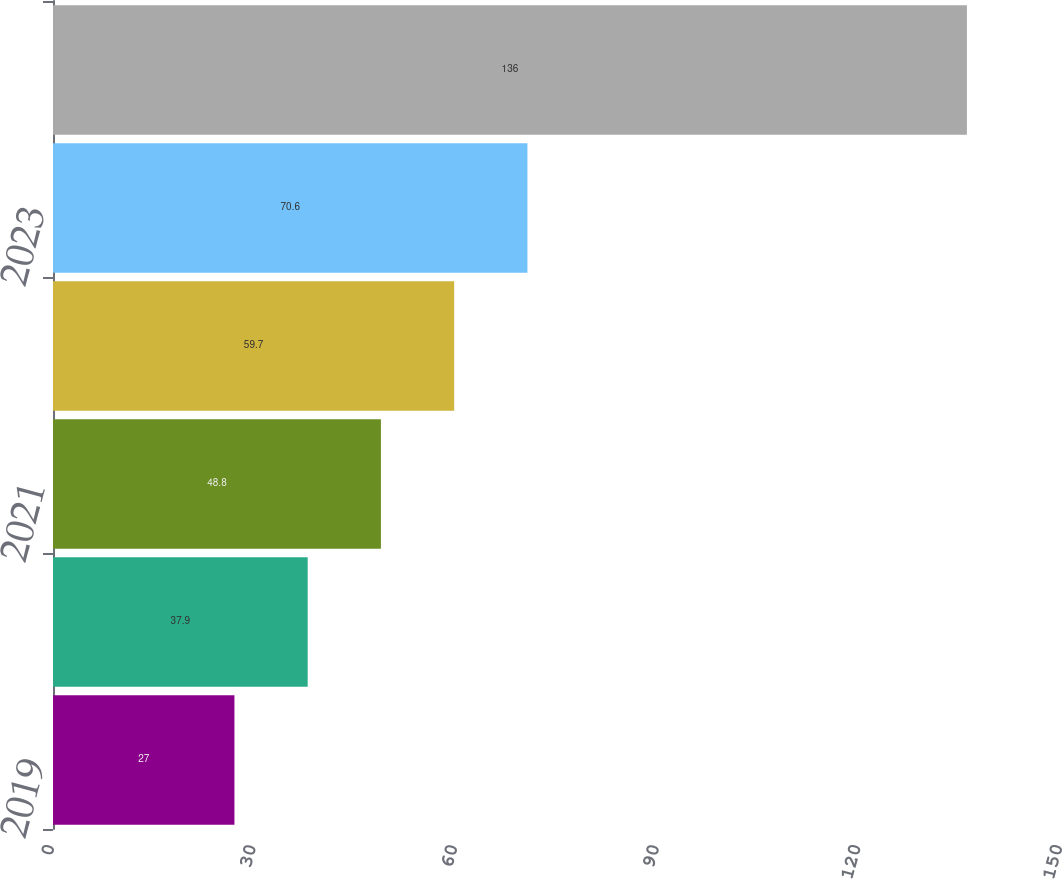<chart> <loc_0><loc_0><loc_500><loc_500><bar_chart><fcel>2019<fcel>2020<fcel>2021<fcel>2022<fcel>2023<fcel>2024-2028<nl><fcel>27<fcel>37.9<fcel>48.8<fcel>59.7<fcel>70.6<fcel>136<nl></chart> 